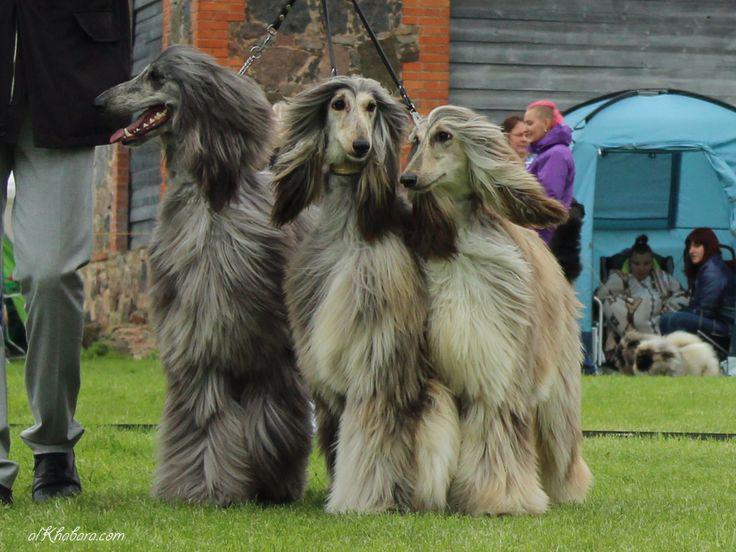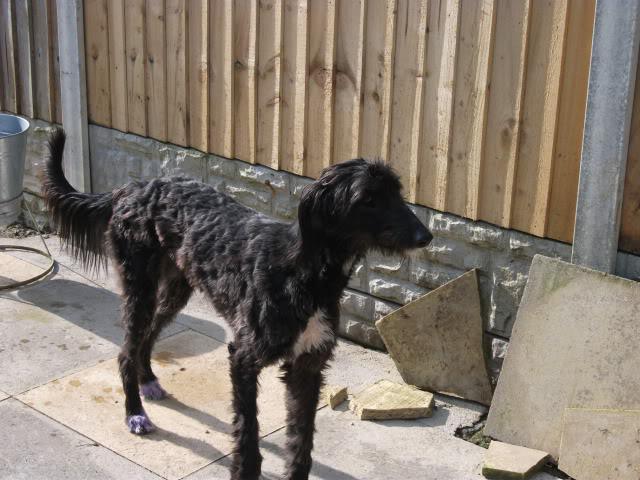The first image is the image on the left, the second image is the image on the right. Assess this claim about the two images: "The dog in the image in the right is standing on in the grass with a person.". Correct or not? Answer yes or no. No. 